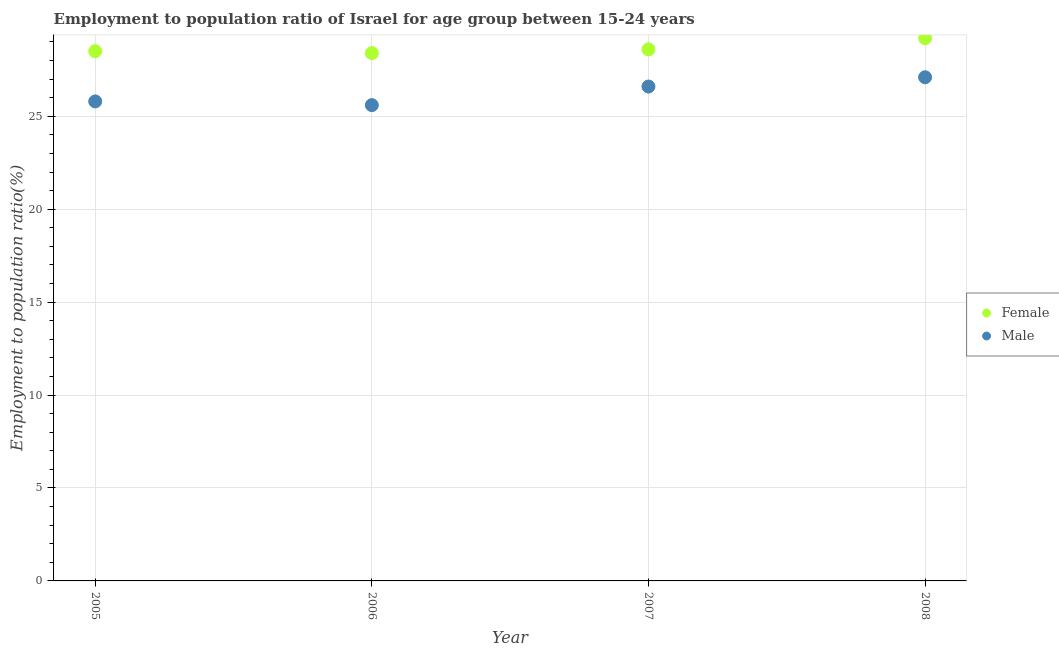Is the number of dotlines equal to the number of legend labels?
Give a very brief answer. Yes. What is the employment to population ratio(female) in 2008?
Offer a terse response. 29.2. Across all years, what is the maximum employment to population ratio(female)?
Offer a very short reply. 29.2. Across all years, what is the minimum employment to population ratio(male)?
Offer a terse response. 25.6. In which year was the employment to population ratio(male) maximum?
Make the answer very short. 2008. What is the total employment to population ratio(female) in the graph?
Your answer should be compact. 114.7. What is the difference between the employment to population ratio(female) in 2006 and the employment to population ratio(male) in 2008?
Ensure brevity in your answer.  1.3. What is the average employment to population ratio(male) per year?
Keep it short and to the point. 26.28. In the year 2005, what is the difference between the employment to population ratio(male) and employment to population ratio(female)?
Provide a short and direct response. -2.7. What is the ratio of the employment to population ratio(female) in 2006 to that in 2007?
Your response must be concise. 0.99. In how many years, is the employment to population ratio(female) greater than the average employment to population ratio(female) taken over all years?
Provide a succinct answer. 1. Is the sum of the employment to population ratio(male) in 2006 and 2008 greater than the maximum employment to population ratio(female) across all years?
Ensure brevity in your answer.  Yes. How many dotlines are there?
Make the answer very short. 2. How many years are there in the graph?
Offer a very short reply. 4. Are the values on the major ticks of Y-axis written in scientific E-notation?
Ensure brevity in your answer.  No. How many legend labels are there?
Your answer should be very brief. 2. What is the title of the graph?
Ensure brevity in your answer.  Employment to population ratio of Israel for age group between 15-24 years. Does "Goods" appear as one of the legend labels in the graph?
Ensure brevity in your answer.  No. What is the label or title of the X-axis?
Keep it short and to the point. Year. What is the label or title of the Y-axis?
Your response must be concise. Employment to population ratio(%). What is the Employment to population ratio(%) of Male in 2005?
Offer a terse response. 25.8. What is the Employment to population ratio(%) of Female in 2006?
Ensure brevity in your answer.  28.4. What is the Employment to population ratio(%) in Male in 2006?
Ensure brevity in your answer.  25.6. What is the Employment to population ratio(%) in Female in 2007?
Your response must be concise. 28.6. What is the Employment to population ratio(%) of Male in 2007?
Ensure brevity in your answer.  26.6. What is the Employment to population ratio(%) in Female in 2008?
Your answer should be compact. 29.2. What is the Employment to population ratio(%) of Male in 2008?
Your response must be concise. 27.1. Across all years, what is the maximum Employment to population ratio(%) in Female?
Provide a succinct answer. 29.2. Across all years, what is the maximum Employment to population ratio(%) in Male?
Give a very brief answer. 27.1. Across all years, what is the minimum Employment to population ratio(%) in Female?
Provide a succinct answer. 28.4. Across all years, what is the minimum Employment to population ratio(%) of Male?
Give a very brief answer. 25.6. What is the total Employment to population ratio(%) of Female in the graph?
Give a very brief answer. 114.7. What is the total Employment to population ratio(%) of Male in the graph?
Your answer should be very brief. 105.1. What is the difference between the Employment to population ratio(%) of Male in 2005 and that in 2007?
Offer a very short reply. -0.8. What is the difference between the Employment to population ratio(%) in Female in 2005 and that in 2008?
Provide a succinct answer. -0.7. What is the difference between the Employment to population ratio(%) of Male in 2006 and that in 2007?
Your response must be concise. -1. What is the difference between the Employment to population ratio(%) in Male in 2006 and that in 2008?
Offer a very short reply. -1.5. What is the difference between the Employment to population ratio(%) in Female in 2005 and the Employment to population ratio(%) in Male in 2008?
Keep it short and to the point. 1.4. What is the difference between the Employment to population ratio(%) of Female in 2006 and the Employment to population ratio(%) of Male in 2007?
Keep it short and to the point. 1.8. What is the difference between the Employment to population ratio(%) in Female in 2006 and the Employment to population ratio(%) in Male in 2008?
Offer a very short reply. 1.3. What is the difference between the Employment to population ratio(%) in Female in 2007 and the Employment to population ratio(%) in Male in 2008?
Provide a succinct answer. 1.5. What is the average Employment to population ratio(%) of Female per year?
Keep it short and to the point. 28.68. What is the average Employment to population ratio(%) of Male per year?
Provide a short and direct response. 26.27. In the year 2005, what is the difference between the Employment to population ratio(%) in Female and Employment to population ratio(%) in Male?
Make the answer very short. 2.7. What is the ratio of the Employment to population ratio(%) of Female in 2005 to that in 2006?
Your answer should be very brief. 1. What is the ratio of the Employment to population ratio(%) in Male in 2005 to that in 2006?
Keep it short and to the point. 1.01. What is the ratio of the Employment to population ratio(%) in Female in 2005 to that in 2007?
Ensure brevity in your answer.  1. What is the ratio of the Employment to population ratio(%) in Male in 2005 to that in 2007?
Keep it short and to the point. 0.97. What is the ratio of the Employment to population ratio(%) of Female in 2005 to that in 2008?
Provide a short and direct response. 0.98. What is the ratio of the Employment to population ratio(%) of Male in 2005 to that in 2008?
Your answer should be very brief. 0.95. What is the ratio of the Employment to population ratio(%) of Male in 2006 to that in 2007?
Give a very brief answer. 0.96. What is the ratio of the Employment to population ratio(%) of Female in 2006 to that in 2008?
Offer a very short reply. 0.97. What is the ratio of the Employment to population ratio(%) of Male in 2006 to that in 2008?
Offer a very short reply. 0.94. What is the ratio of the Employment to population ratio(%) in Female in 2007 to that in 2008?
Your response must be concise. 0.98. What is the ratio of the Employment to population ratio(%) of Male in 2007 to that in 2008?
Your answer should be very brief. 0.98. What is the difference between the highest and the second highest Employment to population ratio(%) in Female?
Provide a succinct answer. 0.6. What is the difference between the highest and the lowest Employment to population ratio(%) in Female?
Give a very brief answer. 0.8. What is the difference between the highest and the lowest Employment to population ratio(%) of Male?
Give a very brief answer. 1.5. 